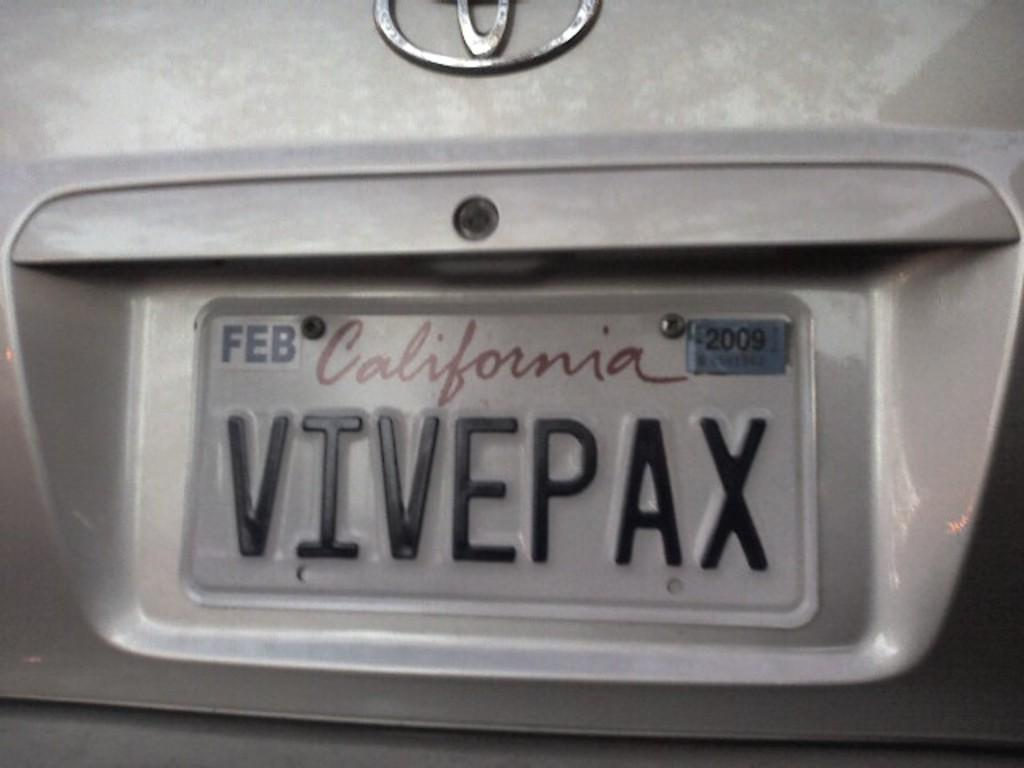<image>
Provide a brief description of the given image. A close up shows the California license plates expire in February 2009. 